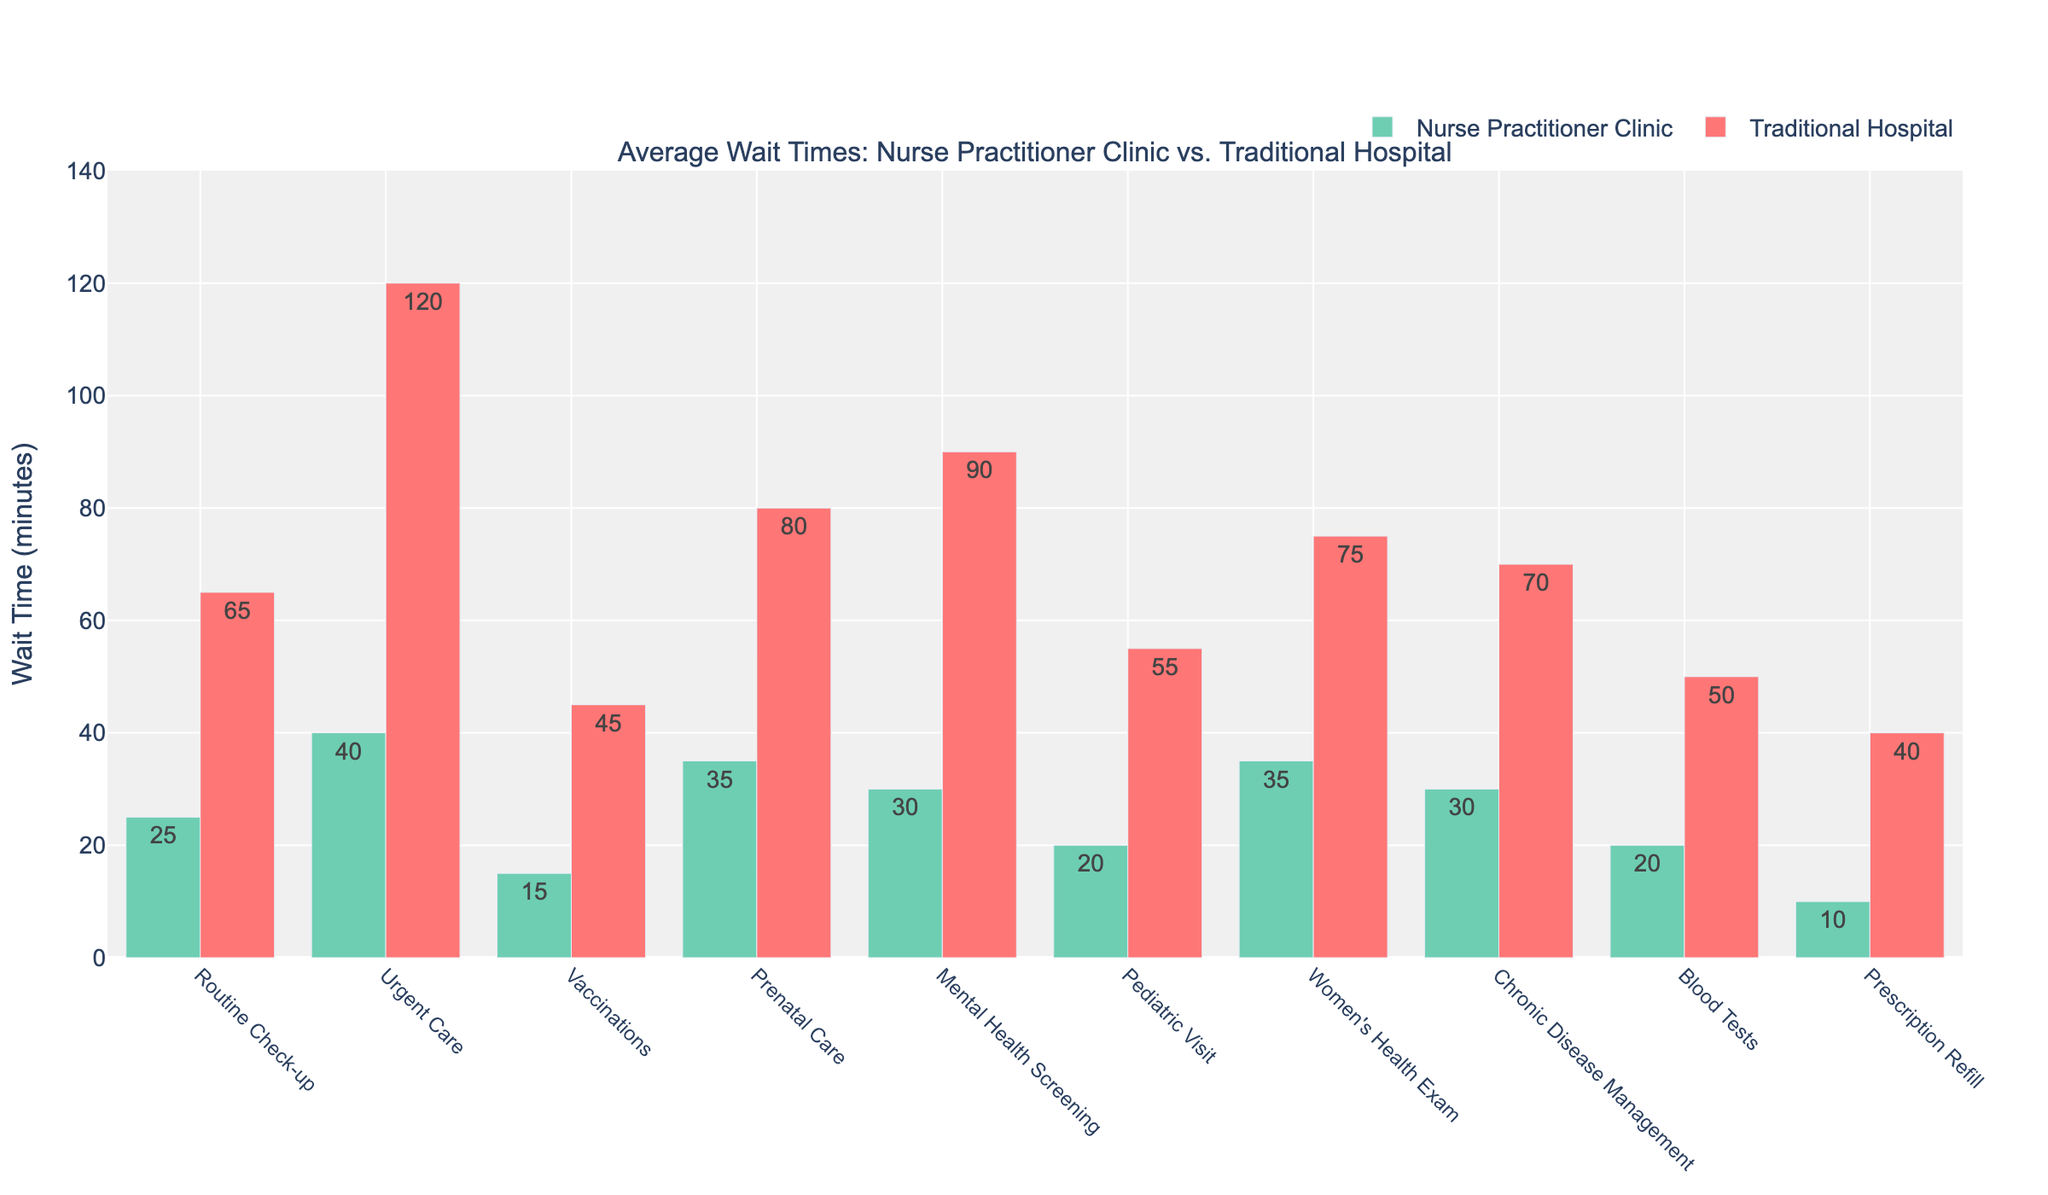Which service has the shortest wait time at Nurse Practitioner Clinics? To determine the service with the shortest wait time, look for the shortest bar (green) corresponding to Nurse Practitioner Clinics. The shortest bar is for Prescription Refill at 10 minutes.
Answer: Prescription Refill What is the difference in wait times for Urgent Care between Nurse Practitioner Clinics and Traditional Hospitals? Locate the bars for Urgent Care. The green bar shows a wait time of 40 minutes at Nurse Practitioner Clinics, and the red bar shows 120 minutes at Traditional Hospitals. The difference is 120 - 40 = 80 minutes.
Answer: 80 minutes Which service shows the largest wait time discrepancy between Nurse Practitioner Clinics and Traditional Hospitals? Compare the differences between the pairs of bars for each service. The largest discrepancy is in Urgent Care, with a difference of 120 - 40 = 80 minutes.
Answer: Urgent Care How much total time would you spend for a Routine Check-up, Urgent Care, and Blood Tests at a Nurse Practitioner Clinic? Sum the wait times for each service at Nurse Practitioner Clinics: Routine Check-up (25 minutes) + Urgent Care (40 minutes) + Blood Tests (20 minutes) = 25 + 40 + 20 = 85 minutes.
Answer: 85 minutes For which services is the wait time at Traditional Hospitals at least double that of Nurse Practitioner Clinics? Identify services where the red bar is at least twice the height of the green bar. They are Routine Check-up (65 vs. 25), Urgent Care (120 vs. 40), Mental Health Screening (90 vs. 30), and Women's Health Exam (75 vs. 35).
Answer: Routine Check-up, Urgent Care, Mental Health Screening, Women's Health Exam Which service has the smallest difference in wait times between Nurse Practitioner Clinics and Traditional Hospitals? Look for the pair of bars with the closest heights. Blood Tests have the smallest difference with 20 minutes at clinics and 50 minutes at hospitals, a difference of 30 minutes.
Answer: Blood Tests What is the average wait time across all services at Nurse Practitioner Clinics? Sum the wait times for all services and divide by the number of services: (25 + 40 + 15 + 35 + 30 + 20 + 35 + 30 + 20 + 10) / 10 = 260 / 10 = 26 minutes.
Answer: 26 minutes For Pediatric Visits, how much more time would you spend at a Traditional Hospital compared to a Nurse Practitioner Clinic? Locate the Pediatric Visit bars: one is 20 minutes at clinics (green bar) and the other is 55 minutes at hospitals (red bar). The difference is 55 - 20 = 35 minutes.
Answer: 35 minutes 